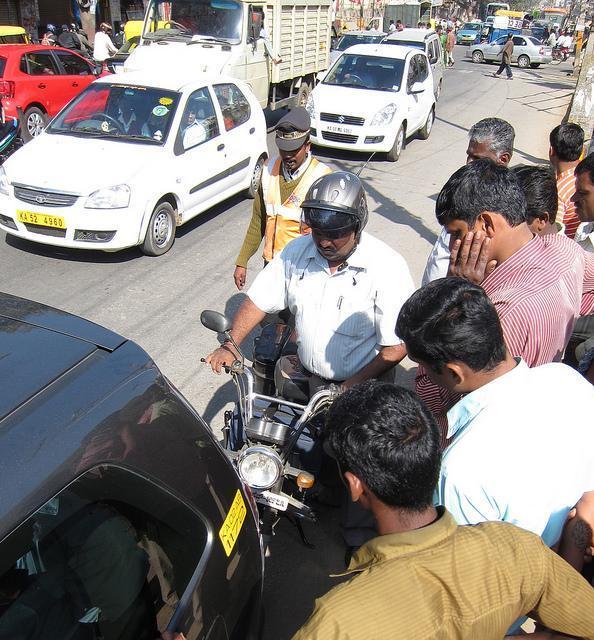How many people are there?
Give a very brief answer. 8. How many cars are in the photo?
Give a very brief answer. 4. How many chairs don't have a dog on them?
Give a very brief answer. 0. 